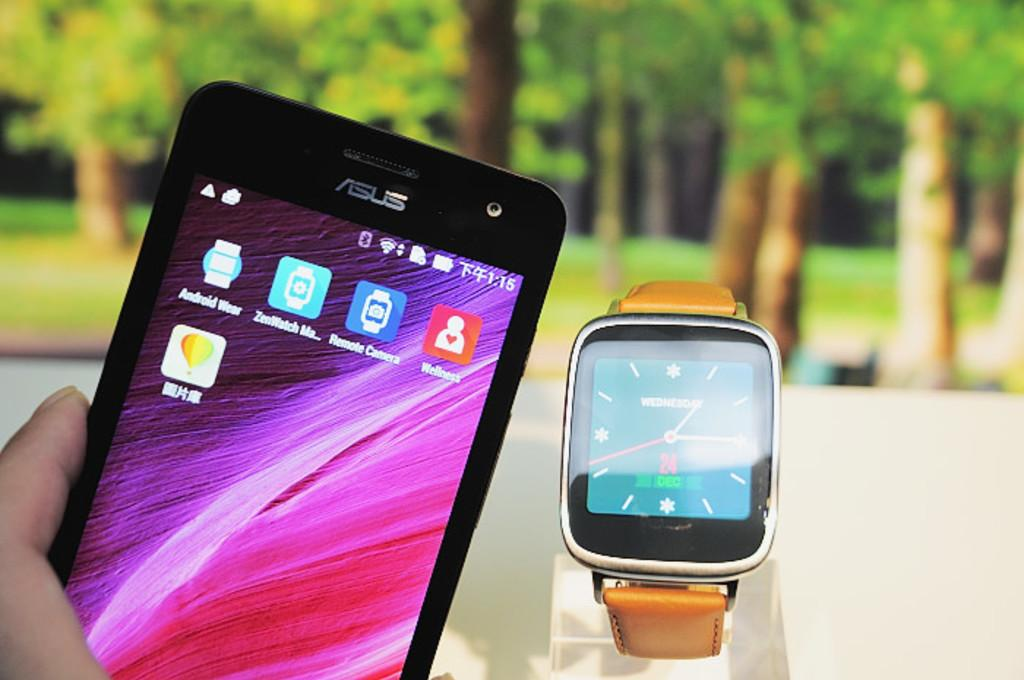Provide a one-sentence caption for the provided image. A bright purple screen is on an Asus cell phone. 